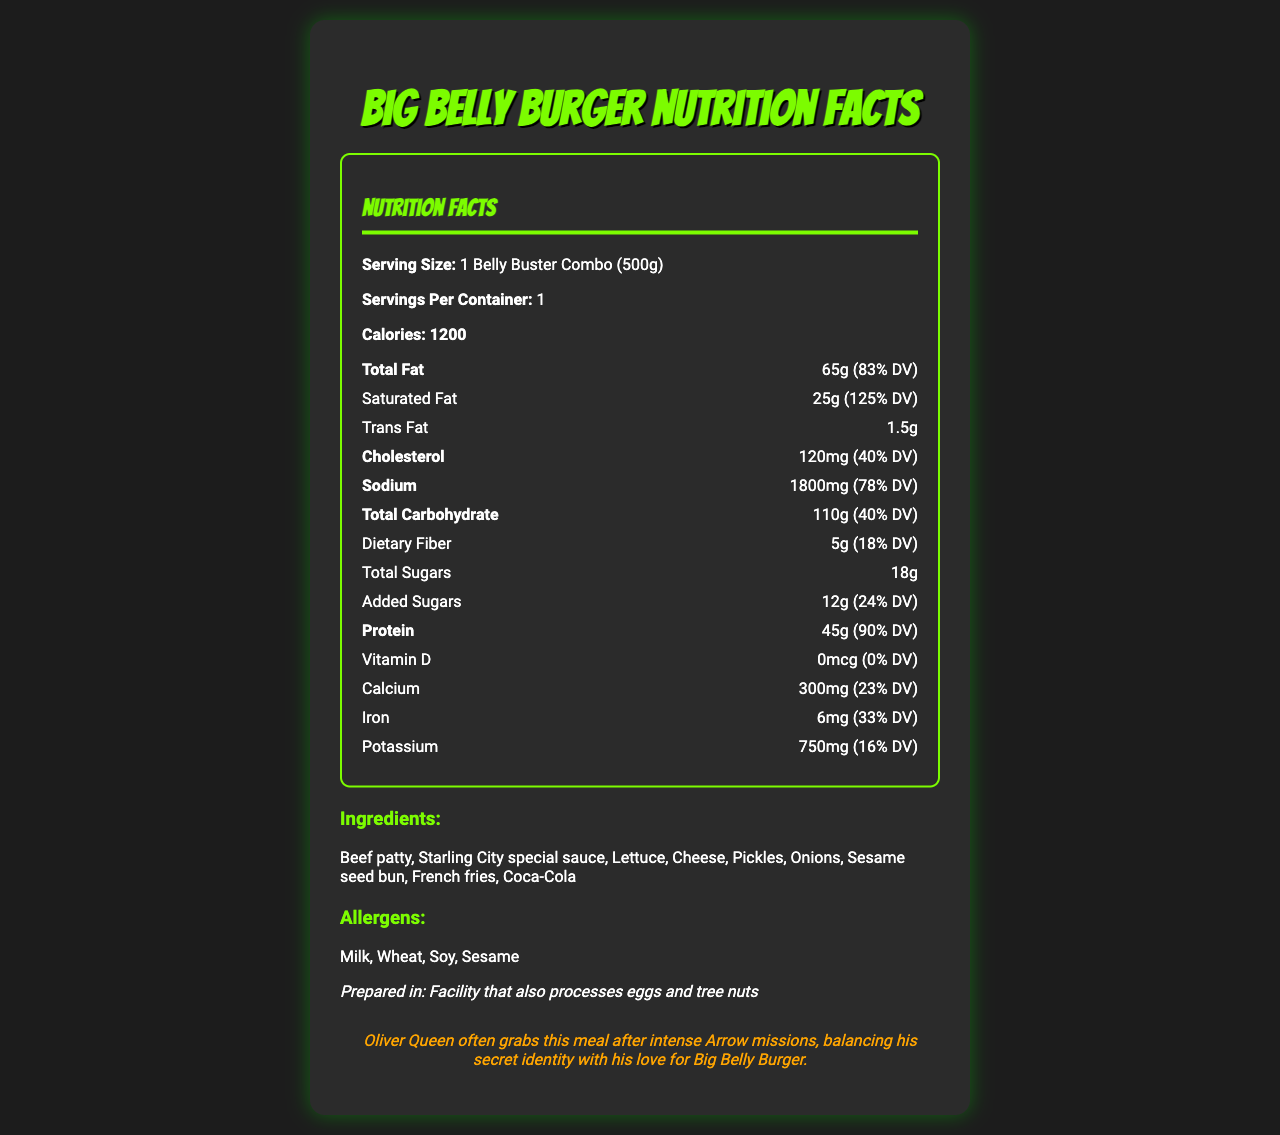What is the serving size of the Big Belly Burger meal? The serving size is directly listed on the document as "1 Belly Buster Combo (500g)".
Answer: 1 Belly Buster Combo (500g) How many servings per container are there for this meal? The document specifies that there is 1 serving per container.
Answer: 1 How many calories are there per serving in Oliver Queen's favorite Big Belly Burger meal? The calorie count per serving is explicitly given as 1200.
Answer: 1200 What percentage of the daily value of saturated fat does one serving contain? The saturated fat content is listed as 25g, which corresponds to 125% of the daily value.
Answer: 125% What is the amount of protein in this meal? The document specifies that the meal contains 45g of protein.
Answer: 45g How much sodium does this meal have? The sodium content per serving is stated as 1800mg.
Answer: 1800mg What are the main ingredients in the Belly Buster Combo? These ingredients are listed under the "Ingredients" section of the document.
Answer: Beef patty, Starling City special sauce, Lettuce, Cheese, Pickles, Onions, Sesame seed bun, French fries, Coca-Cola Which allergens are present in this meal? The allergens are listed under the "Allergens" section of the document.
Answer: Milk, Wheat, Soy, Sesame What percentage of the daily value of total fat does this meal cover? The total fat content is 65g, which represents 83% of the daily value.
Answer: 83% Does this meal contain Vitamin D? The document explicitly states that the Vitamin D content is 0mcg, which is 0% of the daily value.
Answer: No What is the fun fact mentioned about Oliver Queen in relation to this meal? This fun fact is presented in the "fun-fact" section of the document.
Answer: Oliver Queen often grabs this meal after intense Arrow missions, balancing his secret identity with his love for Big Belly Burger. Which of the following nutrients is present in the largest amount?
1. Calcium
2. Protein
3. Iron The meal contains 45g of protein, which is higher than the amounts of calcium (300mg) and iron (6mg).
Answer: 2. Protein Which ingredient of the Belly Buster Combo might be considered a common allergen?
A. Beef patty
B. Cheese
C. Onions
D. French fries Cheese contains milk, which is a listed allergen in the document.
Answer: B. Cheese Can it be determined if this meal is suitable for those with tree nut allergies? The facility that processes the meal also handles tree nuts, which could imply potential cross-contamination, making it unsuitable for those with tree nut allergies.
Answer: No Summarize the document This summary captures all sections of the document, covering nutritional information, ingredients, allergens, and a fun tidbit about Oliver Queen.
Answer: The document provides the nutritional facts for Oliver Queen’s favorite Big Belly Burger meal, detailing the serving size, calories, macronutrients (fat, cholesterol, sodium, carbohydrates, protein), micronutrients (vitamin D, calcium, iron, potassium), ingredients, allergen information, and a fun fact about Oliver Queen's enjoyment of this meal. Is the amount of cholesterol in this meal less than the amount of sodium? The document lists 120mg of cholesterol compared to 1800mg of sodium, thus the cholesterol amount is indeed less than the sodium amount.
Answer: Yes What is the exact preparation location of this meal? The document states that the meal is prepared in a facility that also processes eggs and tree nuts but does not provide a specific location.
Answer: Not enough information 